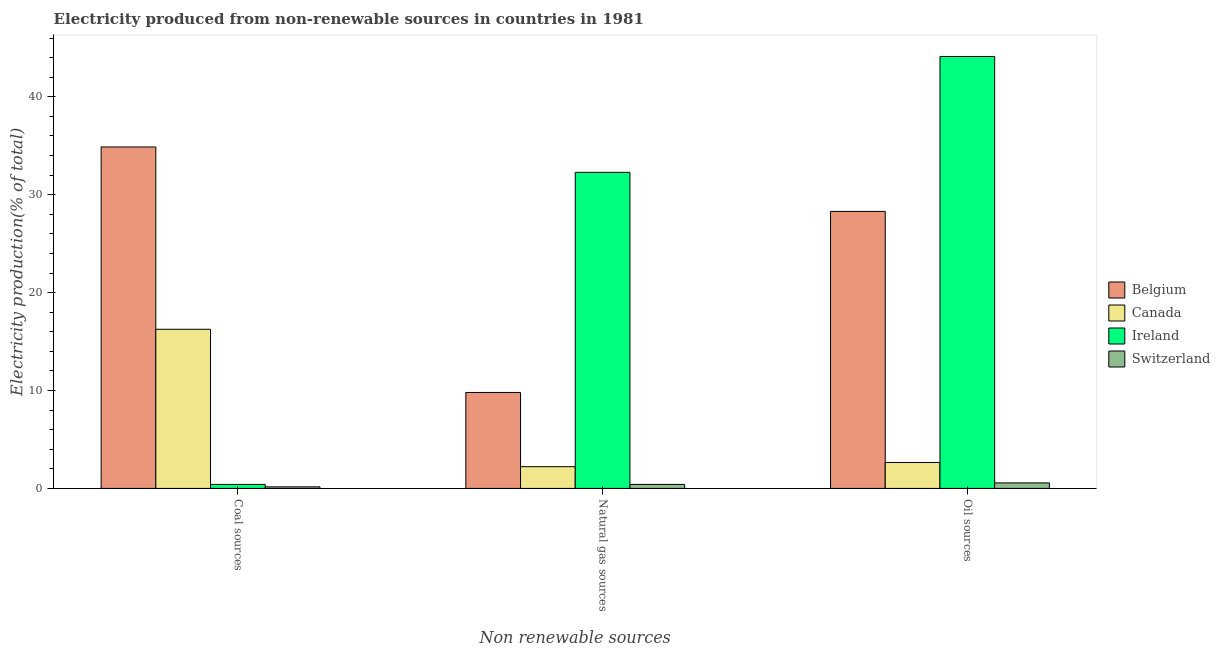Are the number of bars on each tick of the X-axis equal?
Provide a succinct answer. Yes. How many bars are there on the 1st tick from the left?
Give a very brief answer. 4. How many bars are there on the 1st tick from the right?
Provide a succinct answer. 4. What is the label of the 2nd group of bars from the left?
Give a very brief answer. Natural gas sources. What is the percentage of electricity produced by oil sources in Switzerland?
Provide a short and direct response. 0.56. Across all countries, what is the maximum percentage of electricity produced by coal?
Provide a short and direct response. 34.87. Across all countries, what is the minimum percentage of electricity produced by natural gas?
Make the answer very short. 0.41. In which country was the percentage of electricity produced by natural gas maximum?
Make the answer very short. Ireland. In which country was the percentage of electricity produced by coal minimum?
Provide a succinct answer. Switzerland. What is the total percentage of electricity produced by oil sources in the graph?
Provide a short and direct response. 75.62. What is the difference between the percentage of electricity produced by oil sources in Ireland and that in Belgium?
Your response must be concise. 15.83. What is the difference between the percentage of electricity produced by oil sources in Ireland and the percentage of electricity produced by coal in Switzerland?
Ensure brevity in your answer.  43.96. What is the average percentage of electricity produced by oil sources per country?
Keep it short and to the point. 18.9. What is the difference between the percentage of electricity produced by coal and percentage of electricity produced by natural gas in Belgium?
Your response must be concise. 25.07. What is the ratio of the percentage of electricity produced by coal in Switzerland to that in Belgium?
Provide a short and direct response. 0. What is the difference between the highest and the second highest percentage of electricity produced by natural gas?
Your response must be concise. 22.48. What is the difference between the highest and the lowest percentage of electricity produced by natural gas?
Offer a terse response. 31.87. Is the sum of the percentage of electricity produced by natural gas in Switzerland and Belgium greater than the maximum percentage of electricity produced by coal across all countries?
Your response must be concise. No. What does the 3rd bar from the left in Oil sources represents?
Keep it short and to the point. Ireland. What does the 1st bar from the right in Natural gas sources represents?
Provide a succinct answer. Switzerland. How many bars are there?
Offer a very short reply. 12. How many countries are there in the graph?
Provide a short and direct response. 4. Does the graph contain any zero values?
Your answer should be compact. No. Where does the legend appear in the graph?
Keep it short and to the point. Center right. How many legend labels are there?
Provide a short and direct response. 4. How are the legend labels stacked?
Offer a very short reply. Vertical. What is the title of the graph?
Provide a succinct answer. Electricity produced from non-renewable sources in countries in 1981. What is the label or title of the X-axis?
Your answer should be compact. Non renewable sources. What is the Electricity production(% of total) of Belgium in Coal sources?
Give a very brief answer. 34.87. What is the Electricity production(% of total) of Canada in Coal sources?
Provide a succinct answer. 16.26. What is the Electricity production(% of total) in Ireland in Coal sources?
Give a very brief answer. 0.41. What is the Electricity production(% of total) in Switzerland in Coal sources?
Your answer should be very brief. 0.16. What is the Electricity production(% of total) in Belgium in Natural gas sources?
Provide a succinct answer. 9.8. What is the Electricity production(% of total) in Canada in Natural gas sources?
Provide a succinct answer. 2.22. What is the Electricity production(% of total) of Ireland in Natural gas sources?
Provide a succinct answer. 32.28. What is the Electricity production(% of total) of Switzerland in Natural gas sources?
Provide a succinct answer. 0.41. What is the Electricity production(% of total) in Belgium in Oil sources?
Ensure brevity in your answer.  28.29. What is the Electricity production(% of total) of Canada in Oil sources?
Your answer should be compact. 2.65. What is the Electricity production(% of total) of Ireland in Oil sources?
Provide a succinct answer. 44.12. What is the Electricity production(% of total) of Switzerland in Oil sources?
Offer a terse response. 0.56. Across all Non renewable sources, what is the maximum Electricity production(% of total) of Belgium?
Provide a short and direct response. 34.87. Across all Non renewable sources, what is the maximum Electricity production(% of total) of Canada?
Ensure brevity in your answer.  16.26. Across all Non renewable sources, what is the maximum Electricity production(% of total) of Ireland?
Keep it short and to the point. 44.12. Across all Non renewable sources, what is the maximum Electricity production(% of total) of Switzerland?
Provide a succinct answer. 0.56. Across all Non renewable sources, what is the minimum Electricity production(% of total) in Belgium?
Provide a short and direct response. 9.8. Across all Non renewable sources, what is the minimum Electricity production(% of total) in Canada?
Keep it short and to the point. 2.22. Across all Non renewable sources, what is the minimum Electricity production(% of total) in Ireland?
Your answer should be very brief. 0.41. Across all Non renewable sources, what is the minimum Electricity production(% of total) in Switzerland?
Offer a terse response. 0.16. What is the total Electricity production(% of total) in Belgium in the graph?
Provide a short and direct response. 72.97. What is the total Electricity production(% of total) of Canada in the graph?
Your response must be concise. 21.12. What is the total Electricity production(% of total) in Ireland in the graph?
Your answer should be very brief. 76.81. What is the total Electricity production(% of total) of Switzerland in the graph?
Ensure brevity in your answer.  1.13. What is the difference between the Electricity production(% of total) of Belgium in Coal sources and that in Natural gas sources?
Keep it short and to the point. 25.07. What is the difference between the Electricity production(% of total) of Canada in Coal sources and that in Natural gas sources?
Your answer should be very brief. 14.04. What is the difference between the Electricity production(% of total) of Ireland in Coal sources and that in Natural gas sources?
Give a very brief answer. -31.87. What is the difference between the Electricity production(% of total) of Switzerland in Coal sources and that in Natural gas sources?
Give a very brief answer. -0.25. What is the difference between the Electricity production(% of total) in Belgium in Coal sources and that in Oil sources?
Provide a succinct answer. 6.58. What is the difference between the Electricity production(% of total) in Canada in Coal sources and that in Oil sources?
Offer a terse response. 13.61. What is the difference between the Electricity production(% of total) of Ireland in Coal sources and that in Oil sources?
Keep it short and to the point. -43.71. What is the difference between the Electricity production(% of total) in Switzerland in Coal sources and that in Oil sources?
Offer a terse response. -0.4. What is the difference between the Electricity production(% of total) of Belgium in Natural gas sources and that in Oil sources?
Make the answer very short. -18.49. What is the difference between the Electricity production(% of total) of Canada in Natural gas sources and that in Oil sources?
Your answer should be compact. -0.43. What is the difference between the Electricity production(% of total) in Ireland in Natural gas sources and that in Oil sources?
Make the answer very short. -11.83. What is the difference between the Electricity production(% of total) in Switzerland in Natural gas sources and that in Oil sources?
Offer a terse response. -0.15. What is the difference between the Electricity production(% of total) in Belgium in Coal sources and the Electricity production(% of total) in Canada in Natural gas sources?
Ensure brevity in your answer.  32.65. What is the difference between the Electricity production(% of total) of Belgium in Coal sources and the Electricity production(% of total) of Ireland in Natural gas sources?
Offer a very short reply. 2.59. What is the difference between the Electricity production(% of total) in Belgium in Coal sources and the Electricity production(% of total) in Switzerland in Natural gas sources?
Your answer should be compact. 34.47. What is the difference between the Electricity production(% of total) of Canada in Coal sources and the Electricity production(% of total) of Ireland in Natural gas sources?
Your response must be concise. -16.03. What is the difference between the Electricity production(% of total) of Canada in Coal sources and the Electricity production(% of total) of Switzerland in Natural gas sources?
Keep it short and to the point. 15.85. What is the difference between the Electricity production(% of total) in Ireland in Coal sources and the Electricity production(% of total) in Switzerland in Natural gas sources?
Your answer should be very brief. -0. What is the difference between the Electricity production(% of total) of Belgium in Coal sources and the Electricity production(% of total) of Canada in Oil sources?
Make the answer very short. 32.23. What is the difference between the Electricity production(% of total) in Belgium in Coal sources and the Electricity production(% of total) in Ireland in Oil sources?
Your response must be concise. -9.24. What is the difference between the Electricity production(% of total) of Belgium in Coal sources and the Electricity production(% of total) of Switzerland in Oil sources?
Keep it short and to the point. 34.31. What is the difference between the Electricity production(% of total) in Canada in Coal sources and the Electricity production(% of total) in Ireland in Oil sources?
Ensure brevity in your answer.  -27.86. What is the difference between the Electricity production(% of total) in Canada in Coal sources and the Electricity production(% of total) in Switzerland in Oil sources?
Ensure brevity in your answer.  15.69. What is the difference between the Electricity production(% of total) of Ireland in Coal sources and the Electricity production(% of total) of Switzerland in Oil sources?
Offer a terse response. -0.15. What is the difference between the Electricity production(% of total) in Belgium in Natural gas sources and the Electricity production(% of total) in Canada in Oil sources?
Your response must be concise. 7.15. What is the difference between the Electricity production(% of total) of Belgium in Natural gas sources and the Electricity production(% of total) of Ireland in Oil sources?
Your response must be concise. -34.32. What is the difference between the Electricity production(% of total) of Belgium in Natural gas sources and the Electricity production(% of total) of Switzerland in Oil sources?
Provide a succinct answer. 9.24. What is the difference between the Electricity production(% of total) of Canada in Natural gas sources and the Electricity production(% of total) of Ireland in Oil sources?
Provide a succinct answer. -41.9. What is the difference between the Electricity production(% of total) of Canada in Natural gas sources and the Electricity production(% of total) of Switzerland in Oil sources?
Provide a short and direct response. 1.66. What is the difference between the Electricity production(% of total) in Ireland in Natural gas sources and the Electricity production(% of total) in Switzerland in Oil sources?
Make the answer very short. 31.72. What is the average Electricity production(% of total) of Belgium per Non renewable sources?
Your response must be concise. 24.32. What is the average Electricity production(% of total) in Canada per Non renewable sources?
Make the answer very short. 7.04. What is the average Electricity production(% of total) in Ireland per Non renewable sources?
Ensure brevity in your answer.  25.6. What is the average Electricity production(% of total) of Switzerland per Non renewable sources?
Offer a terse response. 0.38. What is the difference between the Electricity production(% of total) of Belgium and Electricity production(% of total) of Canada in Coal sources?
Provide a succinct answer. 18.62. What is the difference between the Electricity production(% of total) in Belgium and Electricity production(% of total) in Ireland in Coal sources?
Your answer should be compact. 34.47. What is the difference between the Electricity production(% of total) in Belgium and Electricity production(% of total) in Switzerland in Coal sources?
Offer a terse response. 34.71. What is the difference between the Electricity production(% of total) in Canada and Electricity production(% of total) in Ireland in Coal sources?
Make the answer very short. 15.85. What is the difference between the Electricity production(% of total) in Canada and Electricity production(% of total) in Switzerland in Coal sources?
Offer a terse response. 16.1. What is the difference between the Electricity production(% of total) of Ireland and Electricity production(% of total) of Switzerland in Coal sources?
Make the answer very short. 0.25. What is the difference between the Electricity production(% of total) in Belgium and Electricity production(% of total) in Canada in Natural gas sources?
Your answer should be compact. 7.58. What is the difference between the Electricity production(% of total) in Belgium and Electricity production(% of total) in Ireland in Natural gas sources?
Offer a terse response. -22.48. What is the difference between the Electricity production(% of total) in Belgium and Electricity production(% of total) in Switzerland in Natural gas sources?
Ensure brevity in your answer.  9.39. What is the difference between the Electricity production(% of total) of Canada and Electricity production(% of total) of Ireland in Natural gas sources?
Give a very brief answer. -30.06. What is the difference between the Electricity production(% of total) of Canada and Electricity production(% of total) of Switzerland in Natural gas sources?
Keep it short and to the point. 1.81. What is the difference between the Electricity production(% of total) of Ireland and Electricity production(% of total) of Switzerland in Natural gas sources?
Your response must be concise. 31.87. What is the difference between the Electricity production(% of total) in Belgium and Electricity production(% of total) in Canada in Oil sources?
Offer a terse response. 25.64. What is the difference between the Electricity production(% of total) of Belgium and Electricity production(% of total) of Ireland in Oil sources?
Your answer should be very brief. -15.83. What is the difference between the Electricity production(% of total) of Belgium and Electricity production(% of total) of Switzerland in Oil sources?
Your answer should be very brief. 27.73. What is the difference between the Electricity production(% of total) in Canada and Electricity production(% of total) in Ireland in Oil sources?
Provide a short and direct response. -41.47. What is the difference between the Electricity production(% of total) in Canada and Electricity production(% of total) in Switzerland in Oil sources?
Offer a terse response. 2.08. What is the difference between the Electricity production(% of total) in Ireland and Electricity production(% of total) in Switzerland in Oil sources?
Your answer should be compact. 43.55. What is the ratio of the Electricity production(% of total) of Belgium in Coal sources to that in Natural gas sources?
Ensure brevity in your answer.  3.56. What is the ratio of the Electricity production(% of total) of Canada in Coal sources to that in Natural gas sources?
Your answer should be compact. 7.32. What is the ratio of the Electricity production(% of total) of Ireland in Coal sources to that in Natural gas sources?
Offer a terse response. 0.01. What is the ratio of the Electricity production(% of total) in Switzerland in Coal sources to that in Natural gas sources?
Offer a very short reply. 0.39. What is the ratio of the Electricity production(% of total) in Belgium in Coal sources to that in Oil sources?
Your answer should be very brief. 1.23. What is the ratio of the Electricity production(% of total) in Canada in Coal sources to that in Oil sources?
Offer a very short reply. 6.14. What is the ratio of the Electricity production(% of total) in Ireland in Coal sources to that in Oil sources?
Ensure brevity in your answer.  0.01. What is the ratio of the Electricity production(% of total) of Switzerland in Coal sources to that in Oil sources?
Keep it short and to the point. 0.28. What is the ratio of the Electricity production(% of total) of Belgium in Natural gas sources to that in Oil sources?
Provide a short and direct response. 0.35. What is the ratio of the Electricity production(% of total) of Canada in Natural gas sources to that in Oil sources?
Ensure brevity in your answer.  0.84. What is the ratio of the Electricity production(% of total) of Ireland in Natural gas sources to that in Oil sources?
Provide a short and direct response. 0.73. What is the ratio of the Electricity production(% of total) in Switzerland in Natural gas sources to that in Oil sources?
Your answer should be very brief. 0.73. What is the difference between the highest and the second highest Electricity production(% of total) of Belgium?
Make the answer very short. 6.58. What is the difference between the highest and the second highest Electricity production(% of total) in Canada?
Make the answer very short. 13.61. What is the difference between the highest and the second highest Electricity production(% of total) of Ireland?
Offer a very short reply. 11.83. What is the difference between the highest and the second highest Electricity production(% of total) in Switzerland?
Ensure brevity in your answer.  0.15. What is the difference between the highest and the lowest Electricity production(% of total) of Belgium?
Your answer should be very brief. 25.07. What is the difference between the highest and the lowest Electricity production(% of total) of Canada?
Make the answer very short. 14.04. What is the difference between the highest and the lowest Electricity production(% of total) in Ireland?
Your answer should be very brief. 43.71. What is the difference between the highest and the lowest Electricity production(% of total) of Switzerland?
Provide a short and direct response. 0.4. 